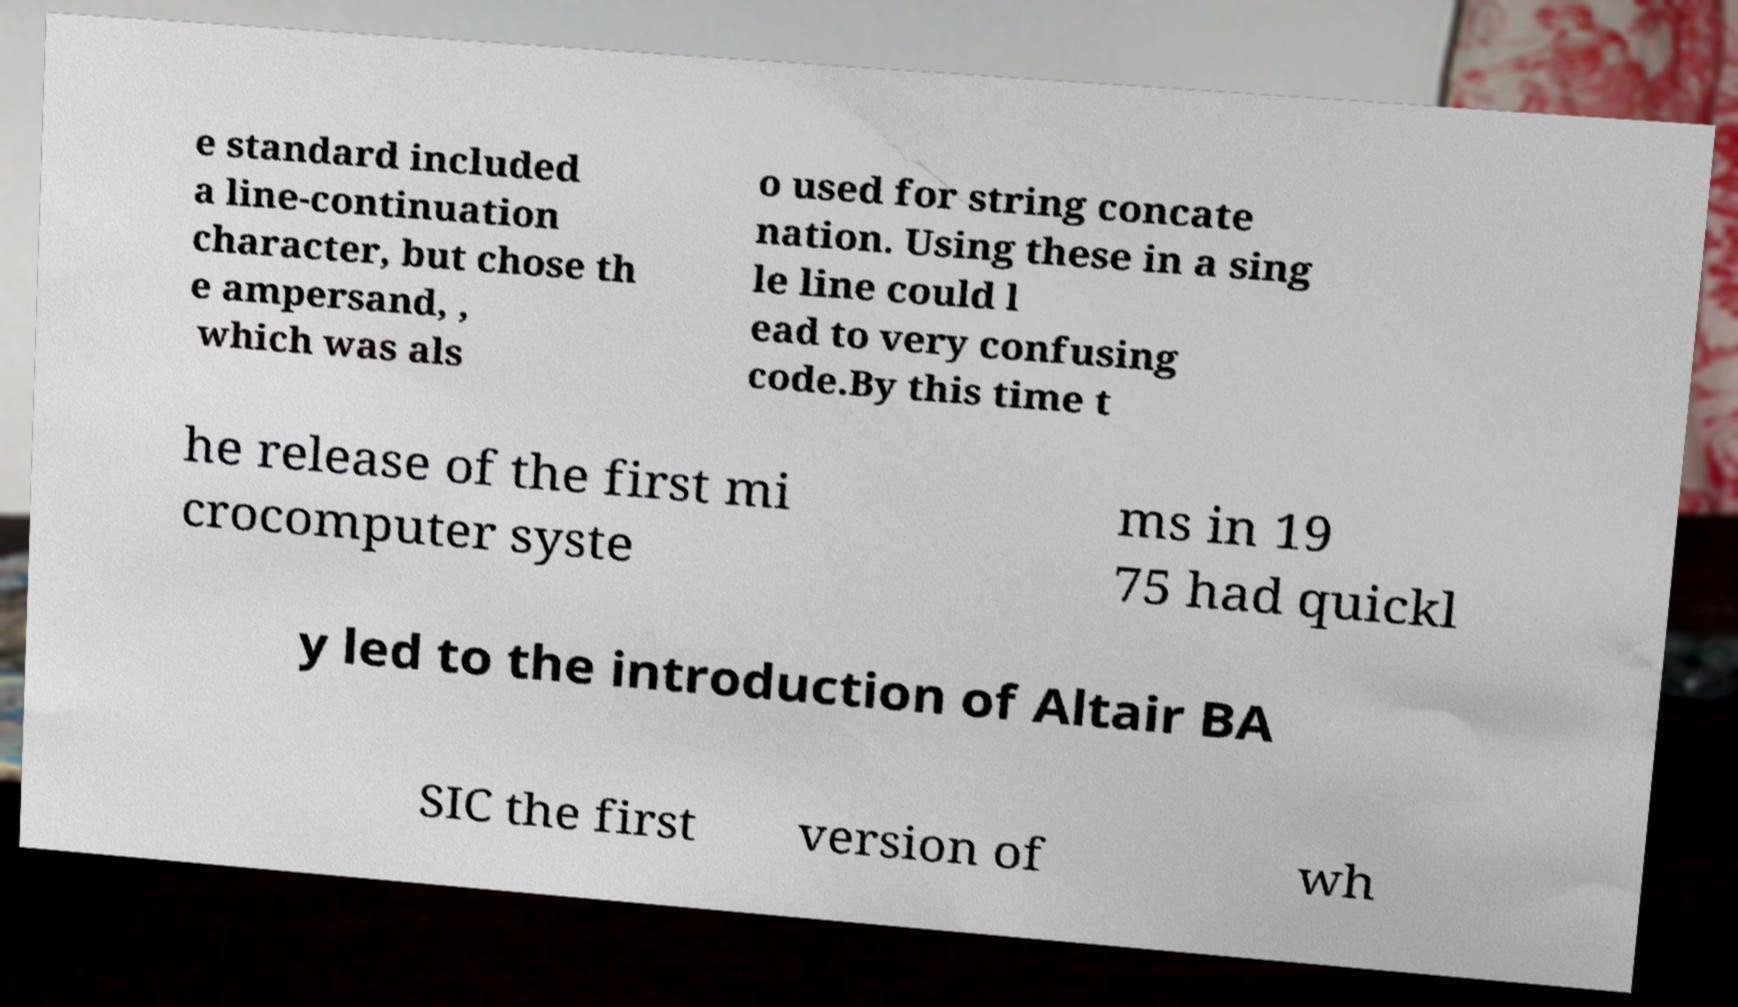Please identify and transcribe the text found in this image. e standard included a line-continuation character, but chose th e ampersand, , which was als o used for string concate nation. Using these in a sing le line could l ead to very confusing code.By this time t he release of the first mi crocomputer syste ms in 19 75 had quickl y led to the introduction of Altair BA SIC the first version of wh 